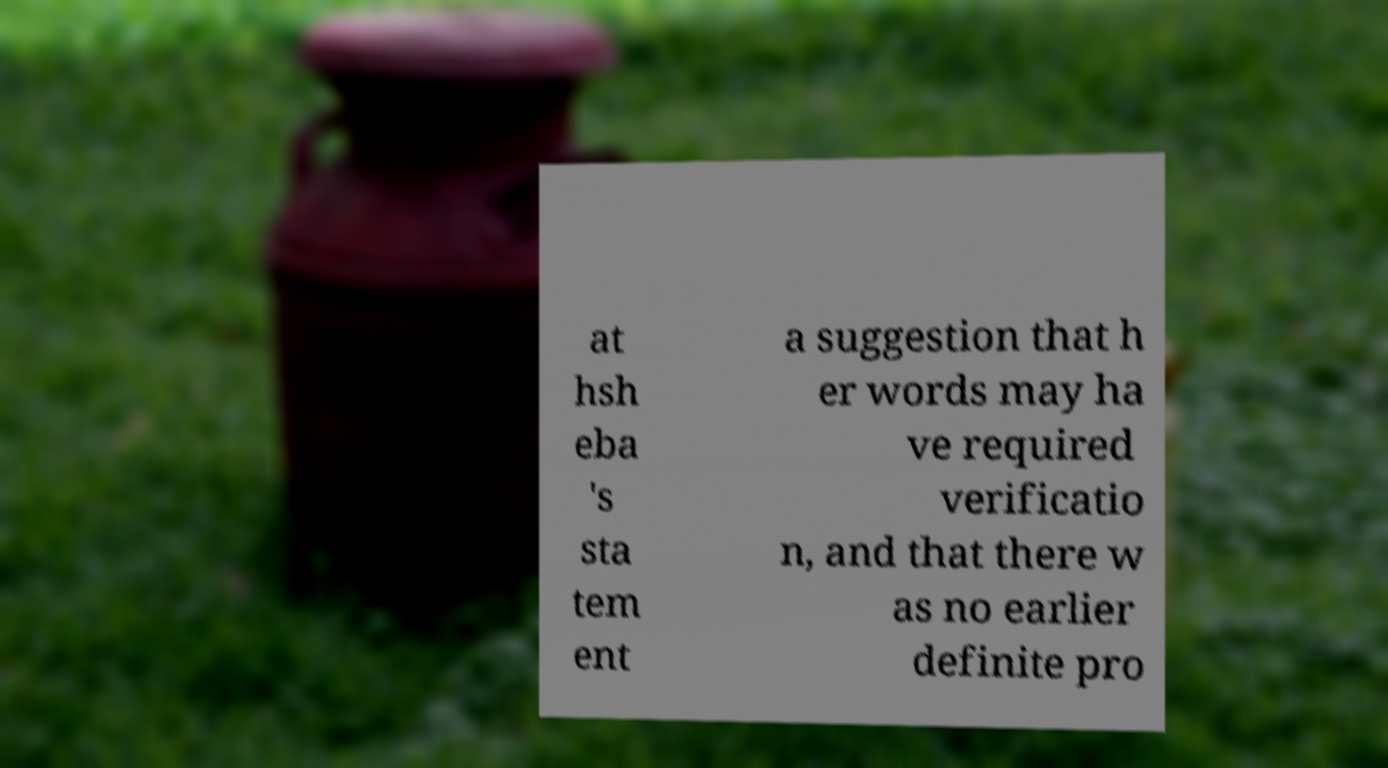For documentation purposes, I need the text within this image transcribed. Could you provide that? at hsh eba 's sta tem ent a suggestion that h er words may ha ve required verificatio n, and that there w as no earlier definite pro 